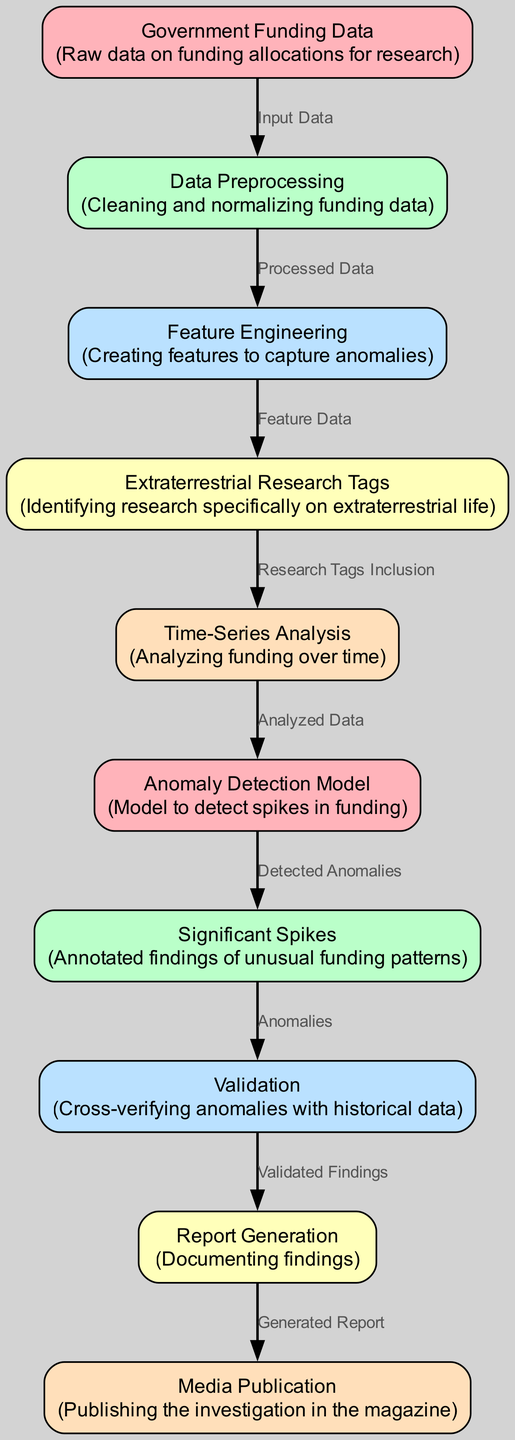What is the total number of nodes in the diagram? The diagram consists of ten nodes that represent different stages in the anomaly detection process for government funding allocations in extraterrestrial research.
Answer: 10 Which node is responsible for cleaning and normalizing funding data? The 'Data Preprocessing' node specifically indicates this step, as described in its label and description.
Answer: Data Preprocessing What is the relationship between 'Extraterrestrial Research Tags' and 'Time-Series Analysis'? The 'Extraterrestrial Research Tags' node provides input to the 'Time-Series Analysis' node, as indicated by the directed edge connecting them.
Answer: Research Tags Inclusion What type of analysis does the 'Anomaly Detection Model' perform? The 'Anomaly Detection Model' detects anomalies, specifically looking for spikes in the funding data related to extraterrestrial research.
Answer: Detects anomalies Explain the process flow from 'Feature Engineering' to 'Report Generation'. The flow begins at the 'Feature Engineering' node, which produces feature data for the 'Extraterrestrial Research Tags' node. Then, the tag information is used in 'Time-Series Analysis', leading to the 'Anomaly Detection Model' that detects anomalies. The findings are then cross-verified in the 'Validation' node, which generates validated findings for the 'Report Generation' node that finally documents the results.
Answer: Feature Engineering → Extraterrestrial Research Tags → Time-Series Analysis → Anomaly Detection Model → Validation → Report Generation What node comes directly after the 'Data Preprocessing' node? After 'Data Preprocessing', the 'Feature Engineering' node follows in the sequence indicated by the directed edge.
Answer: Feature Engineering How are significant anomalies verified within the diagram? Significant anomalies detected by the 'Anomaly Detection Model' are cross-verified in the 'Validation' node with historical data, ensuring their accuracy.
Answer: Cross-verifying anomalies What does the 'Media Publication' node signify in the diagram? The 'Media Publication' node represents the final step where documented findings from the anomaly detection investigation are published in the magazine.
Answer: Publishing the investigation Which node is the starting point of the entire diagram? The diagram begins with the 'Government Funding Data' node, which serves as the initial input for all subsequent processes.
Answer: Government Funding Data 